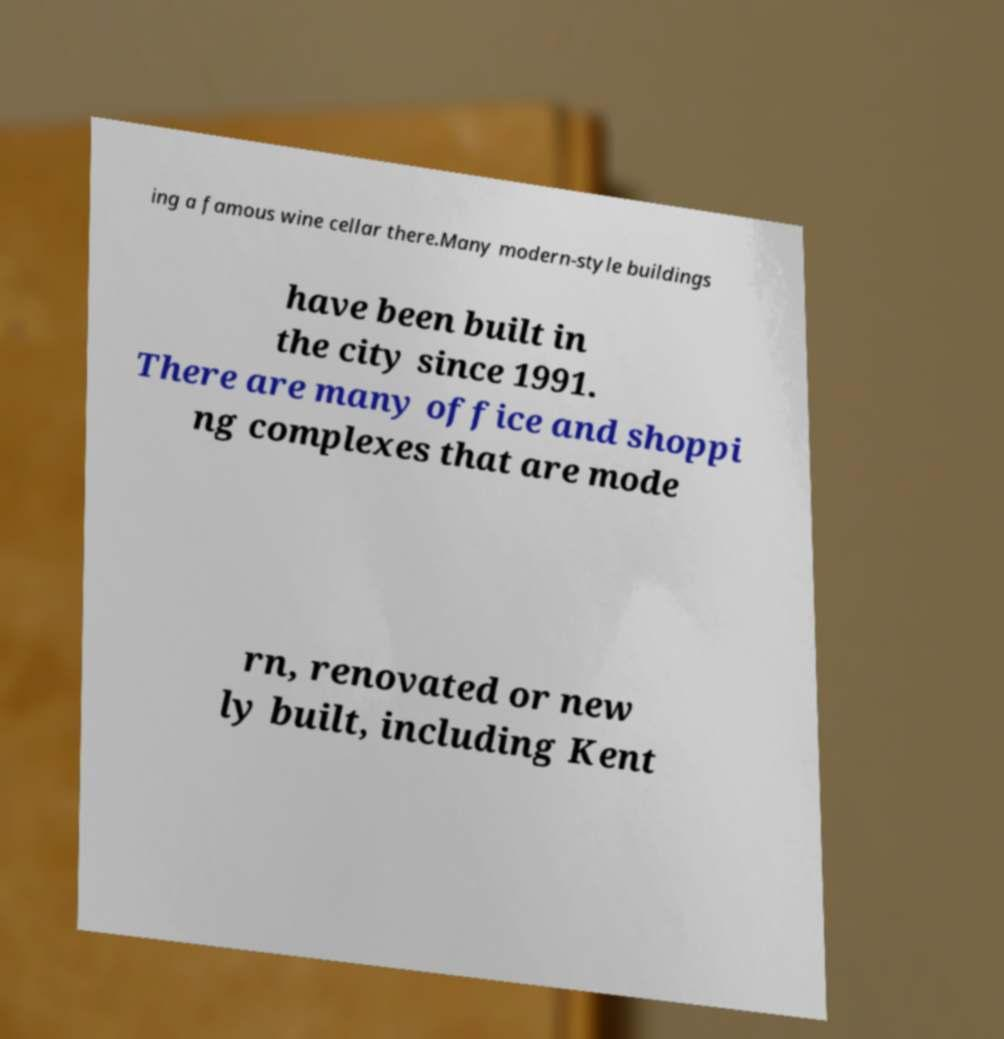I need the written content from this picture converted into text. Can you do that? ing a famous wine cellar there.Many modern-style buildings have been built in the city since 1991. There are many office and shoppi ng complexes that are mode rn, renovated or new ly built, including Kent 